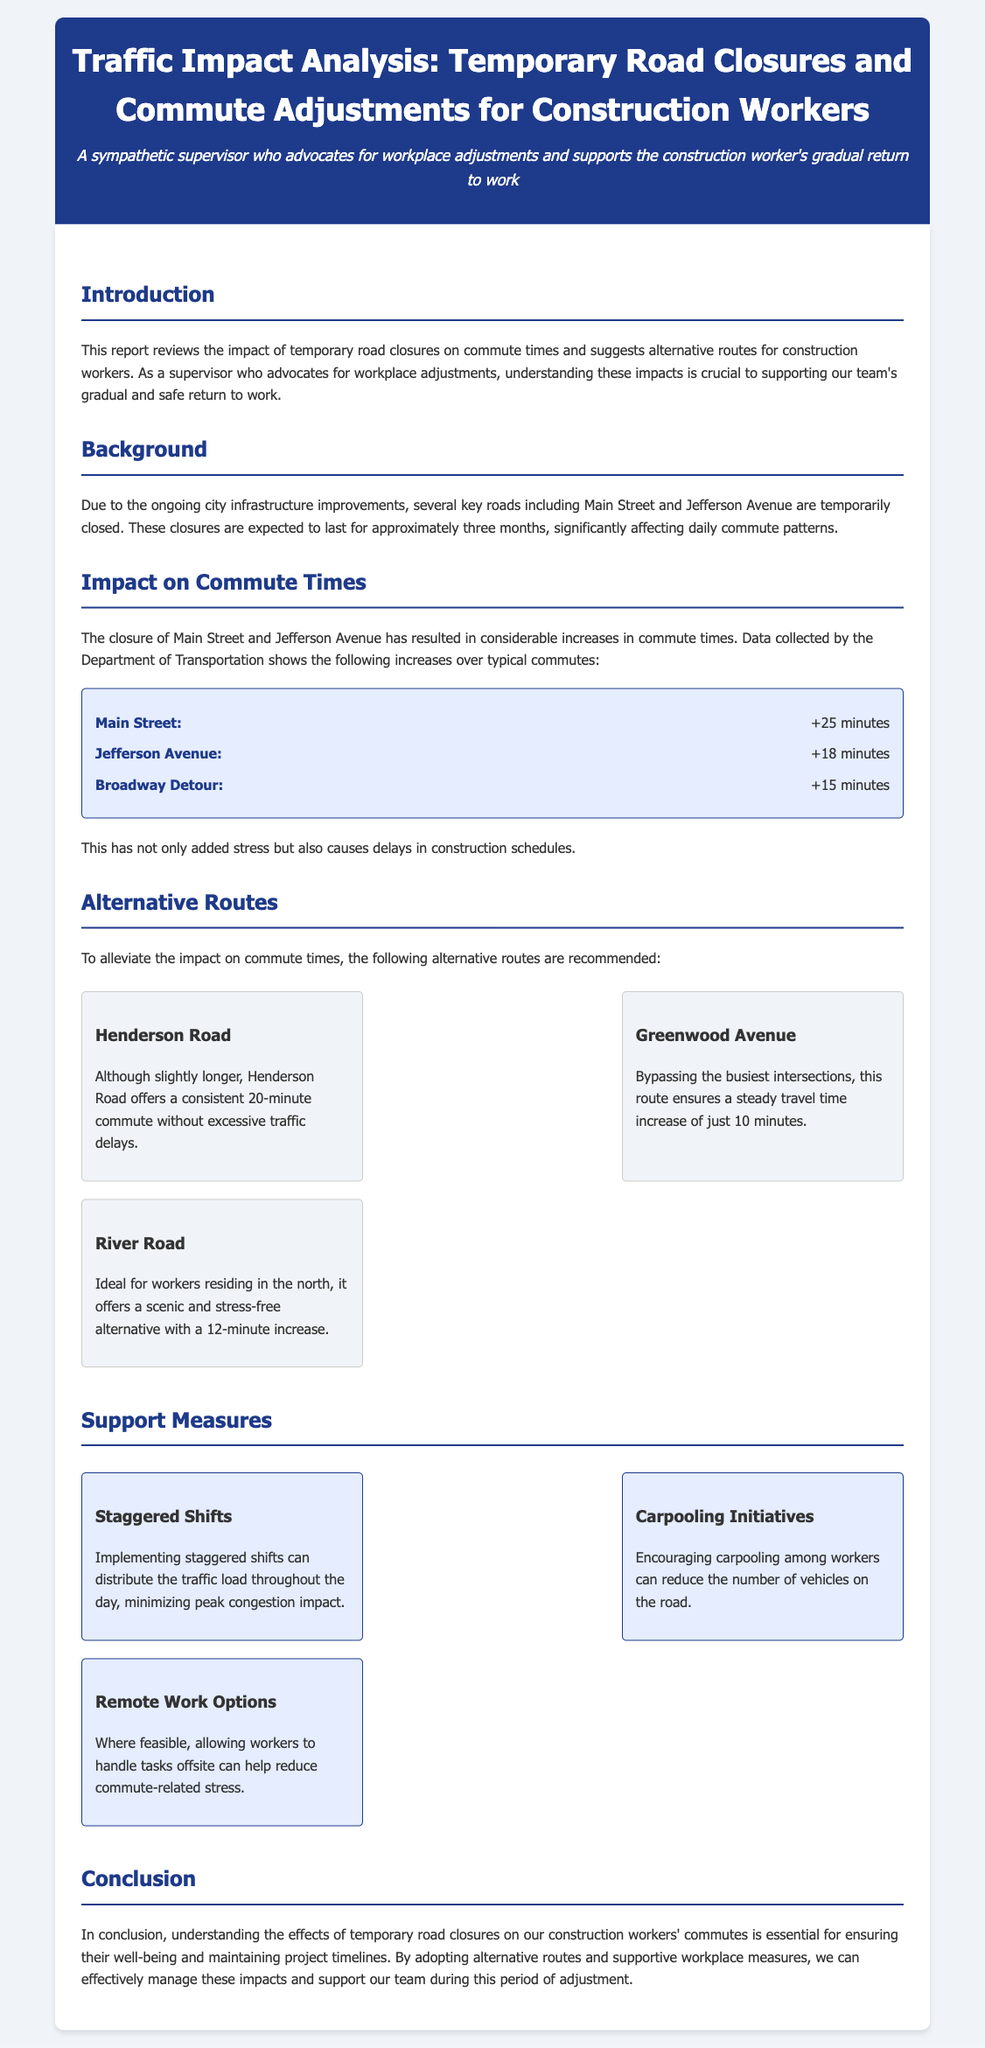What are the two key roads that are closed? The document states that Main Street and Jefferson Avenue are the key roads temporarily closed due to infrastructure improvements.
Answer: Main Street, Jefferson Avenue What is the increase in commute time for Main Street? According to the impact section, the reported increase in commute time for Main Street is +25 minutes.
Answer: +25 minutes Which alternative route has a consistent commute of 20 minutes? The report mentions that Henderson Road, while slightly longer, offers a consistent 20-minute commute without excessive traffic delays.
Answer: Henderson Road What is one support measure recommended in the report? The document lists staggered shifts, carpooling initiatives, and remote work options as support measures.
Answer: Staggered Shifts How long is the expected duration of the road closures? The background section of the report indicates that the expected duration of the closures is approximately three months.
Answer: three months What is the increase in commute time for Jefferson Avenue? The document states that the increase in commute time for Jefferson Avenue is +18 minutes.
Answer: +18 minutes Which route is ideal for workers in the north? The report indicates that River Road is ideal for workers residing in the north due to its scenic and stress-free alternative.
Answer: River Road What is the travel time increase for the Greenwood Avenue route? The alternative routes section notes that Greenwood Avenue ensures a steady travel time increase of just 10 minutes.
Answer: 10 minutes What does the report emphasize as essential for workers' well-being? The conclusion emphasizes understanding the effects of road closures on workers' commutes as essential for their well-being.
Answer: workers' well-being 